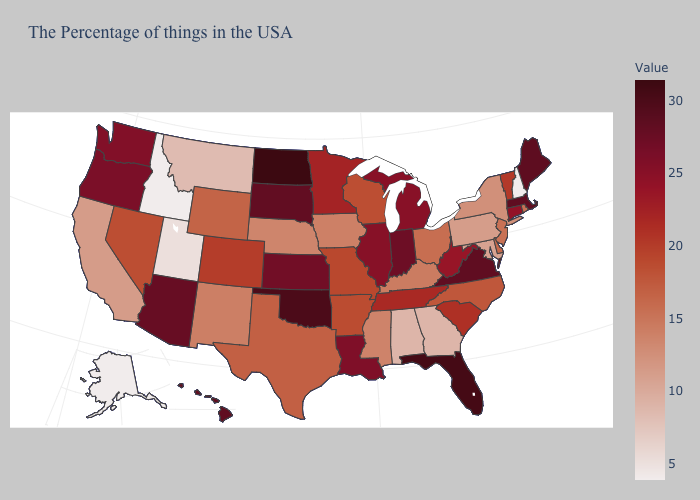Among the states that border Massachusetts , does Connecticut have the highest value?
Concise answer only. Yes. Which states have the highest value in the USA?
Keep it brief. North Dakota. Does New Jersey have a lower value than Hawaii?
Short answer required. Yes. Does New Jersey have the highest value in the Northeast?
Write a very short answer. No. 